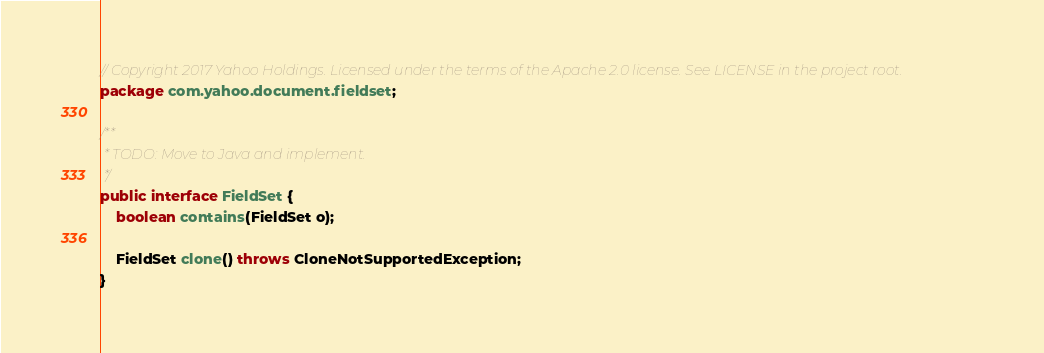<code> <loc_0><loc_0><loc_500><loc_500><_Java_>// Copyright 2017 Yahoo Holdings. Licensed under the terms of the Apache 2.0 license. See LICENSE in the project root.
package com.yahoo.document.fieldset;

/**
 * TODO: Move to Java and implement.
 */
public interface FieldSet {
    boolean contains(FieldSet o);

    FieldSet clone() throws CloneNotSupportedException;
}
</code> 